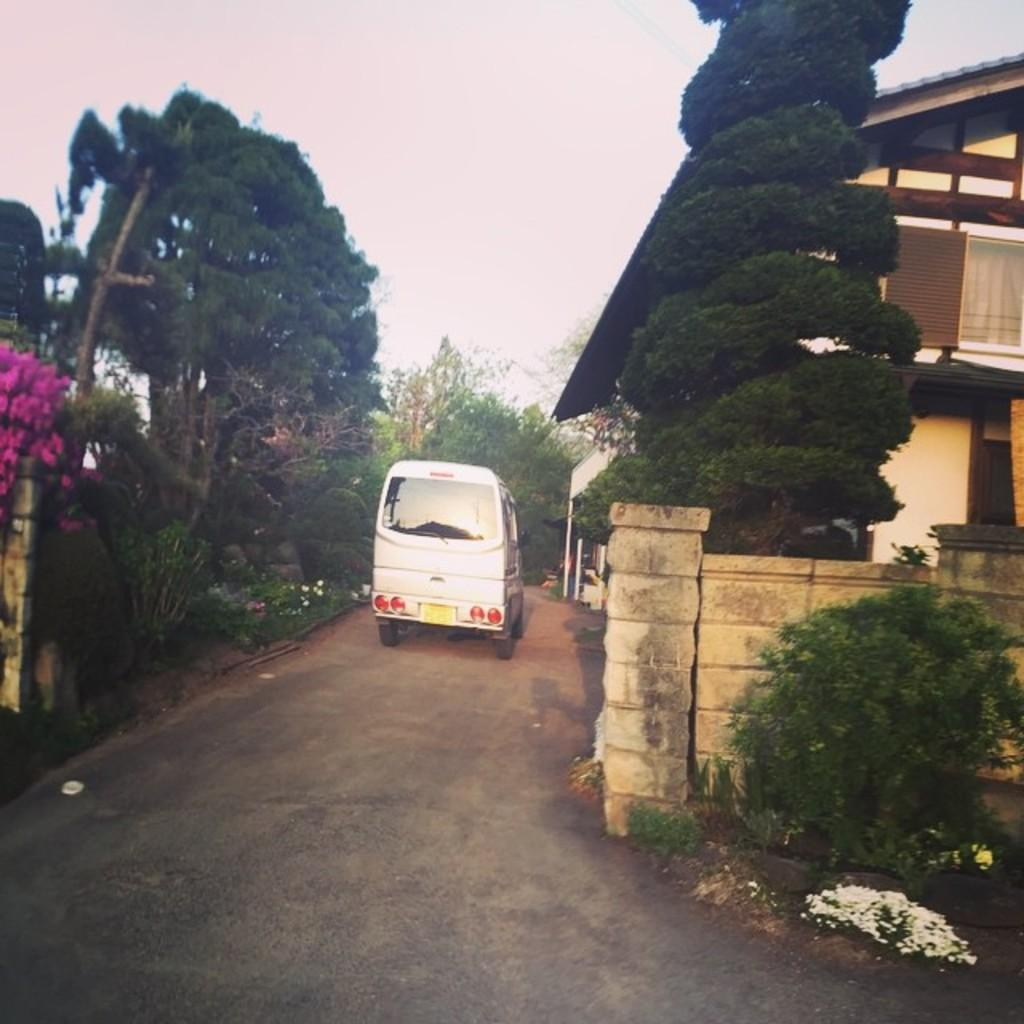What is parked in front of the building in the image? There is a vehicle parked in front of a building in the image. What can be seen around the building? There are trees surrounding the area in the image. What type of theory is being discussed in the scene depicted in the image? There is no scene or discussion present in the image; it simply shows a vehicle parked in front of a building with trees surrounding the area. Can you see any goats in the image? No, there are no goats present in the image. 